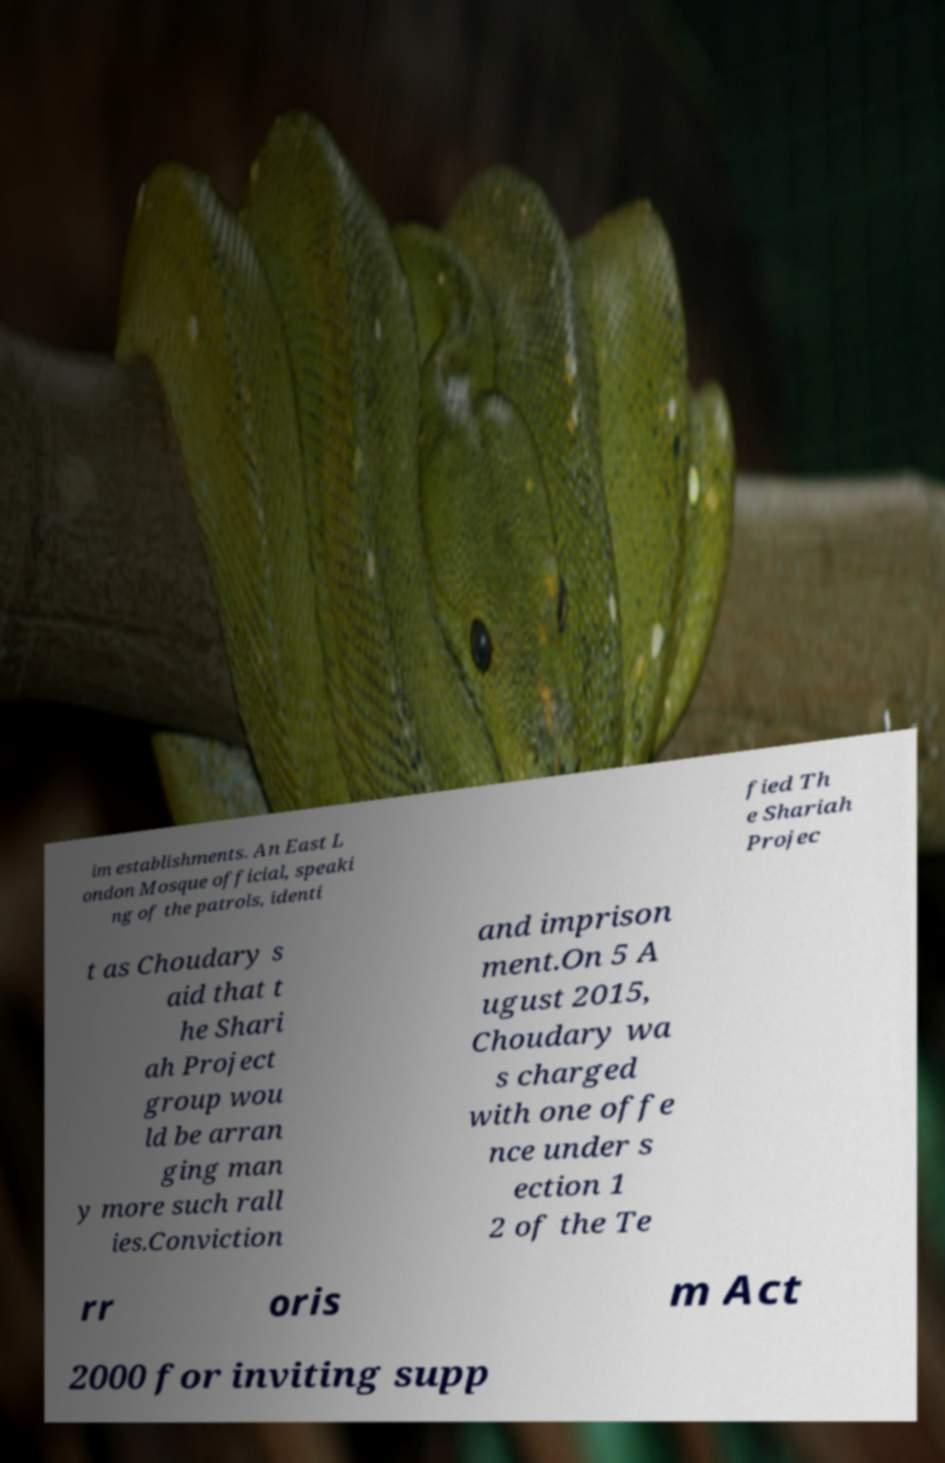For documentation purposes, I need the text within this image transcribed. Could you provide that? im establishments. An East L ondon Mosque official, speaki ng of the patrols, identi fied Th e Shariah Projec t as Choudary s aid that t he Shari ah Project group wou ld be arran ging man y more such rall ies.Conviction and imprison ment.On 5 A ugust 2015, Choudary wa s charged with one offe nce under s ection 1 2 of the Te rr oris m Act 2000 for inviting supp 